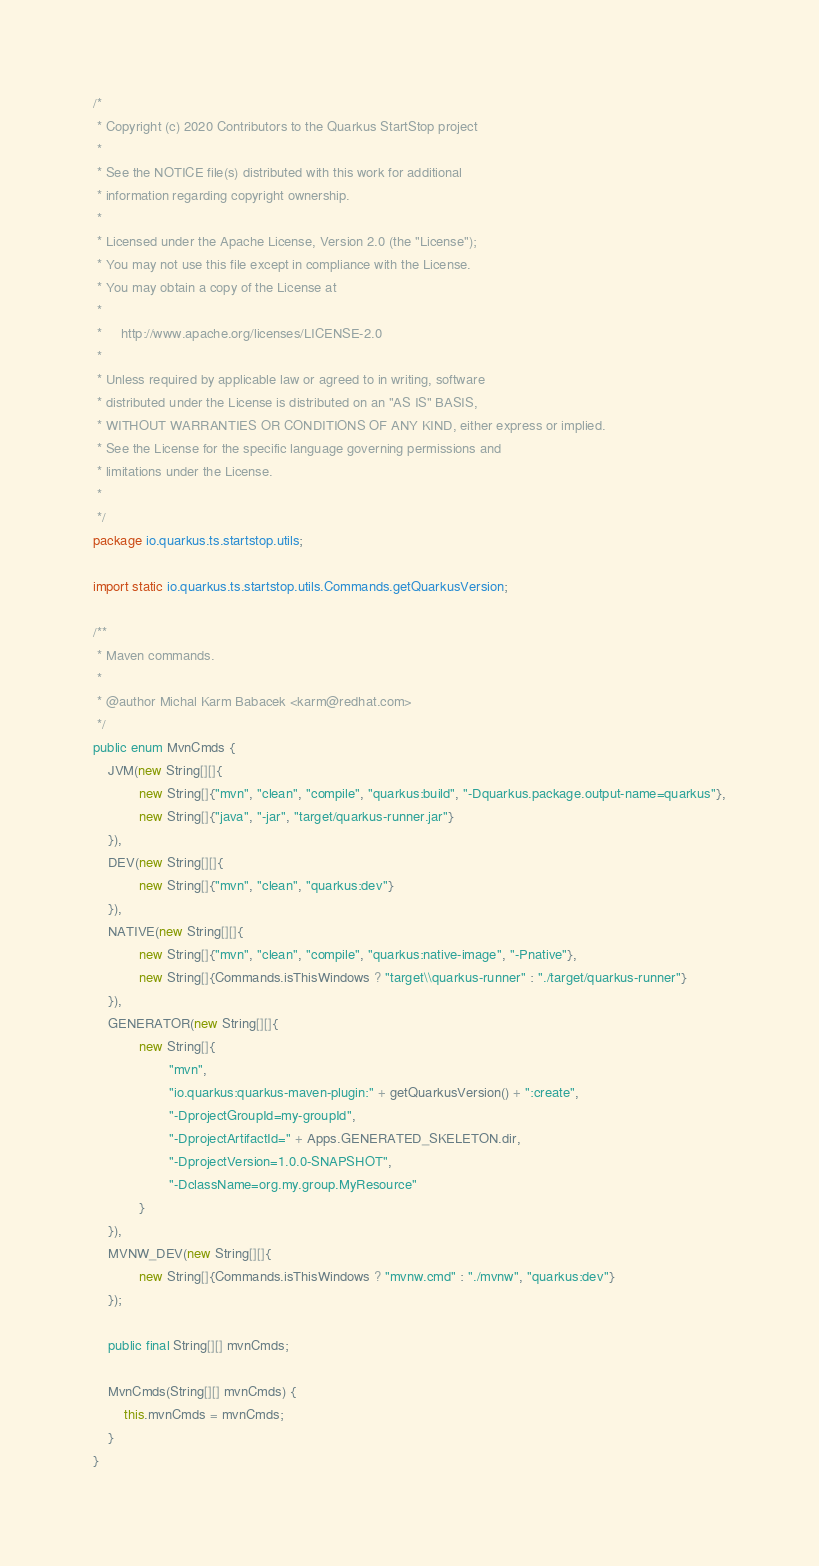Convert code to text. <code><loc_0><loc_0><loc_500><loc_500><_Java_>/*
 * Copyright (c) 2020 Contributors to the Quarkus StartStop project
 *
 * See the NOTICE file(s) distributed with this work for additional
 * information regarding copyright ownership.
 *
 * Licensed under the Apache License, Version 2.0 (the "License");
 * You may not use this file except in compliance with the License.
 * You may obtain a copy of the License at
 *
 *     http://www.apache.org/licenses/LICENSE-2.0
 *
 * Unless required by applicable law or agreed to in writing, software
 * distributed under the License is distributed on an "AS IS" BASIS,
 * WITHOUT WARRANTIES OR CONDITIONS OF ANY KIND, either express or implied.
 * See the License for the specific language governing permissions and
 * limitations under the License.
 *
 */
package io.quarkus.ts.startstop.utils;

import static io.quarkus.ts.startstop.utils.Commands.getQuarkusVersion;

/**
 * Maven commands.
 *
 * @author Michal Karm Babacek <karm@redhat.com>
 */
public enum MvnCmds {
    JVM(new String[][]{
            new String[]{"mvn", "clean", "compile", "quarkus:build", "-Dquarkus.package.output-name=quarkus"},
            new String[]{"java", "-jar", "target/quarkus-runner.jar"}
    }),
    DEV(new String[][]{
            new String[]{"mvn", "clean", "quarkus:dev"}
    }),
    NATIVE(new String[][]{
            new String[]{"mvn", "clean", "compile", "quarkus:native-image", "-Pnative"},
            new String[]{Commands.isThisWindows ? "target\\quarkus-runner" : "./target/quarkus-runner"}
    }),
    GENERATOR(new String[][]{
            new String[]{
                    "mvn",
                    "io.quarkus:quarkus-maven-plugin:" + getQuarkusVersion() + ":create",
                    "-DprojectGroupId=my-groupId",
                    "-DprojectArtifactId=" + Apps.GENERATED_SKELETON.dir,
                    "-DprojectVersion=1.0.0-SNAPSHOT",
                    "-DclassName=org.my.group.MyResource"
            }
    }),
    MVNW_DEV(new String[][]{
            new String[]{Commands.isThisWindows ? "mvnw.cmd" : "./mvnw", "quarkus:dev"}
    });

    public final String[][] mvnCmds;

    MvnCmds(String[][] mvnCmds) {
        this.mvnCmds = mvnCmds;
    }
}
</code> 